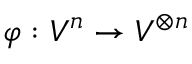<formula> <loc_0><loc_0><loc_500><loc_500>\varphi \colon V ^ { n } \to V ^ { \otimes n }</formula> 